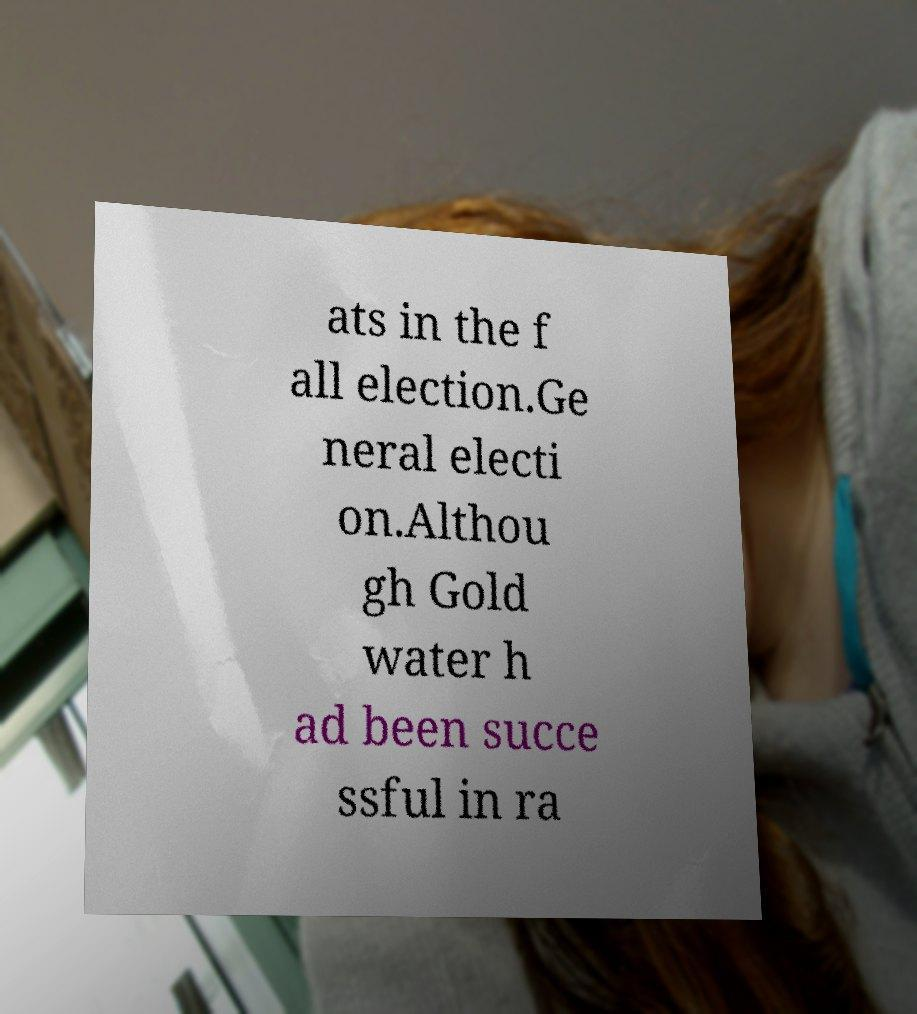Please identify and transcribe the text found in this image. ats in the f all election.Ge neral electi on.Althou gh Gold water h ad been succe ssful in ra 